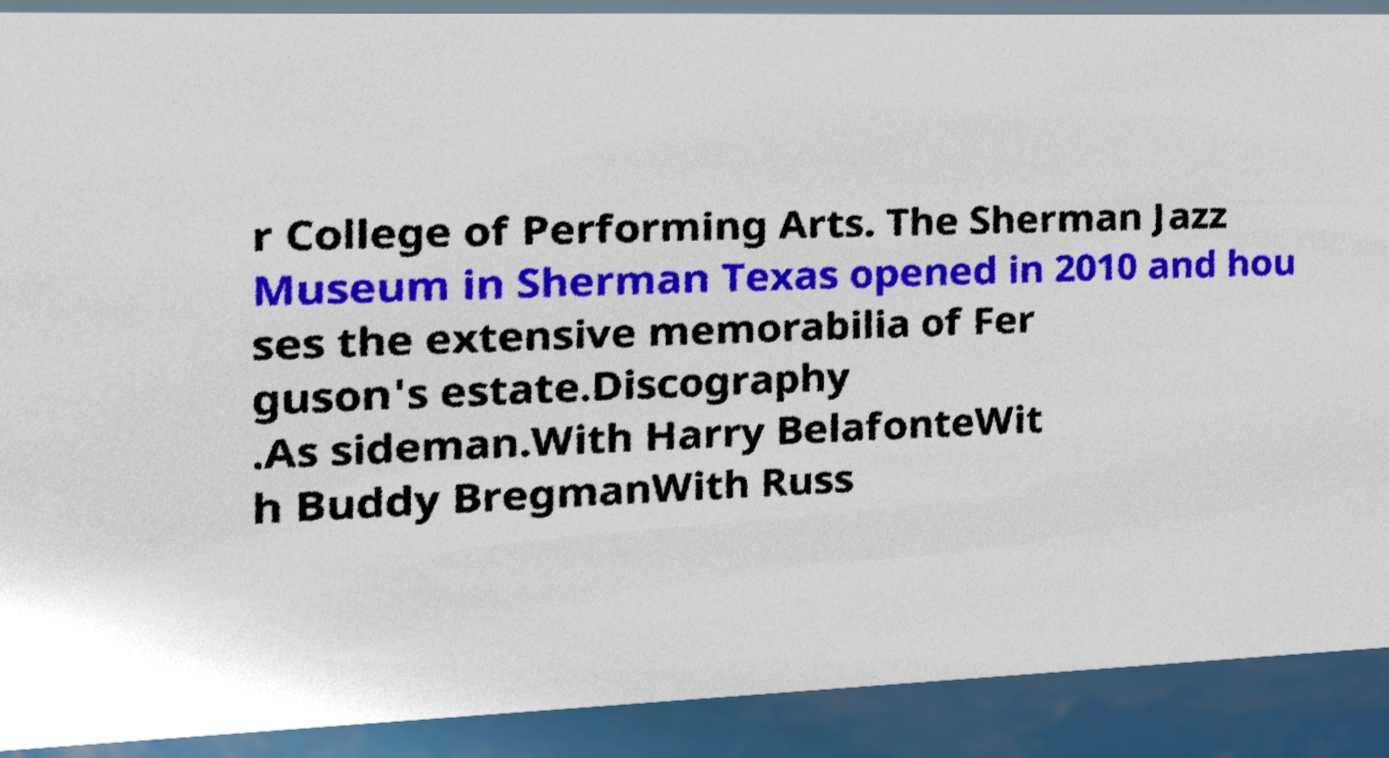Can you read and provide the text displayed in the image?This photo seems to have some interesting text. Can you extract and type it out for me? r College of Performing Arts. The Sherman Jazz Museum in Sherman Texas opened in 2010 and hou ses the extensive memorabilia of Fer guson's estate.Discography .As sideman.With Harry BelafonteWit h Buddy BregmanWith Russ 